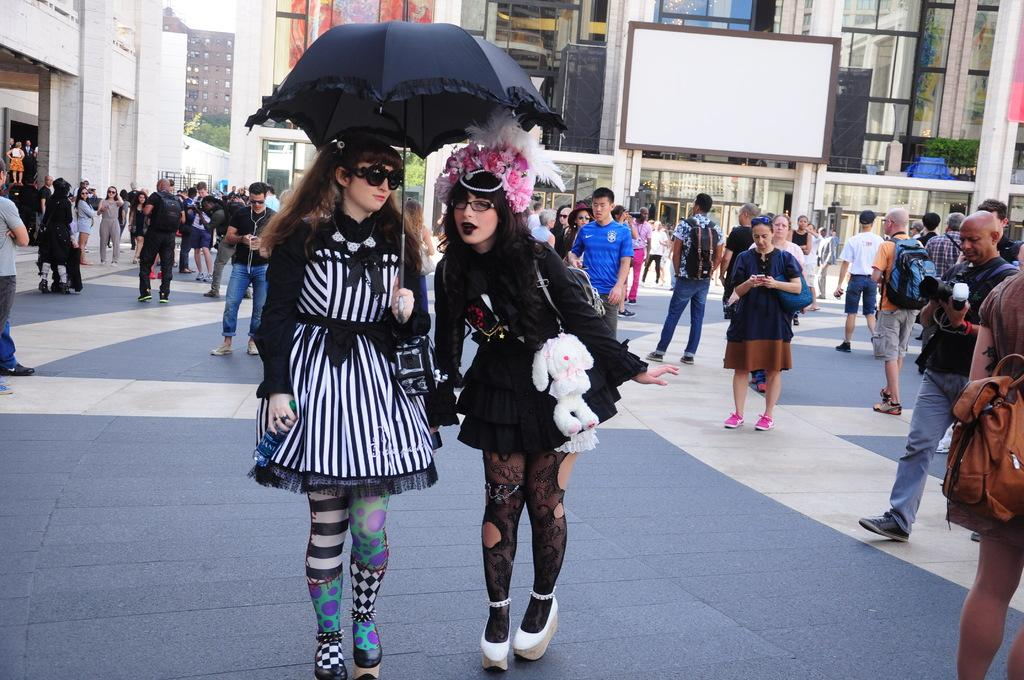How many women are in the image? There are 2 women in the image. What are the women doing in the image? The women are standing and holding an umbrella. Can you describe the background of the image? There are other people and buildings in the background of the image. What object is visible in the image that might be used for writing or displaying information? There is a white board visible in the image. What type of voice can be heard coming from the tray in the image? There is no tray present in the image, and therefore no voice can be heard coming from it. 